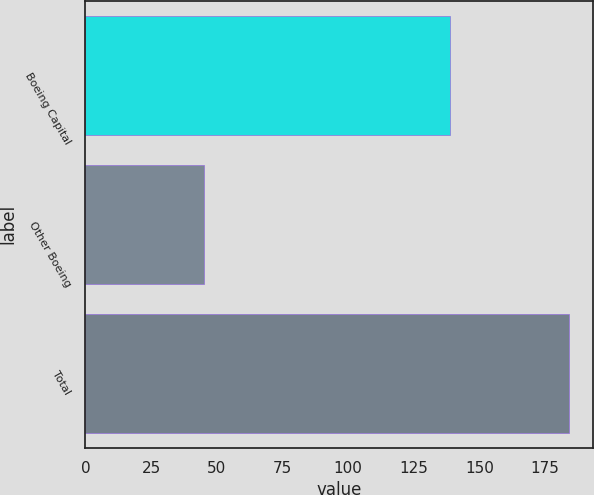Convert chart. <chart><loc_0><loc_0><loc_500><loc_500><bar_chart><fcel>Boeing Capital<fcel>Other Boeing<fcel>Total<nl><fcel>139<fcel>45<fcel>184<nl></chart> 